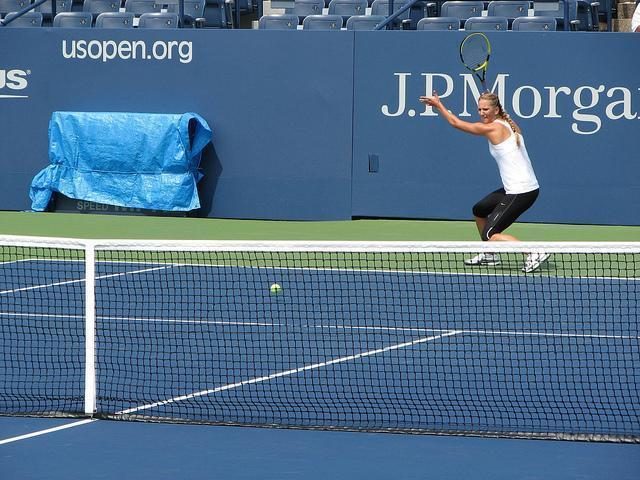How many slices is this pizza cut into?
Give a very brief answer. 0. 